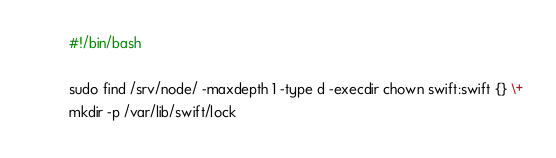<code> <loc_0><loc_0><loc_500><loc_500><_Bash_>#!/bin/bash

sudo find /srv/node/ -maxdepth 1 -type d -execdir chown swift:swift {} \+
mkdir -p /var/lib/swift/lock
</code> 